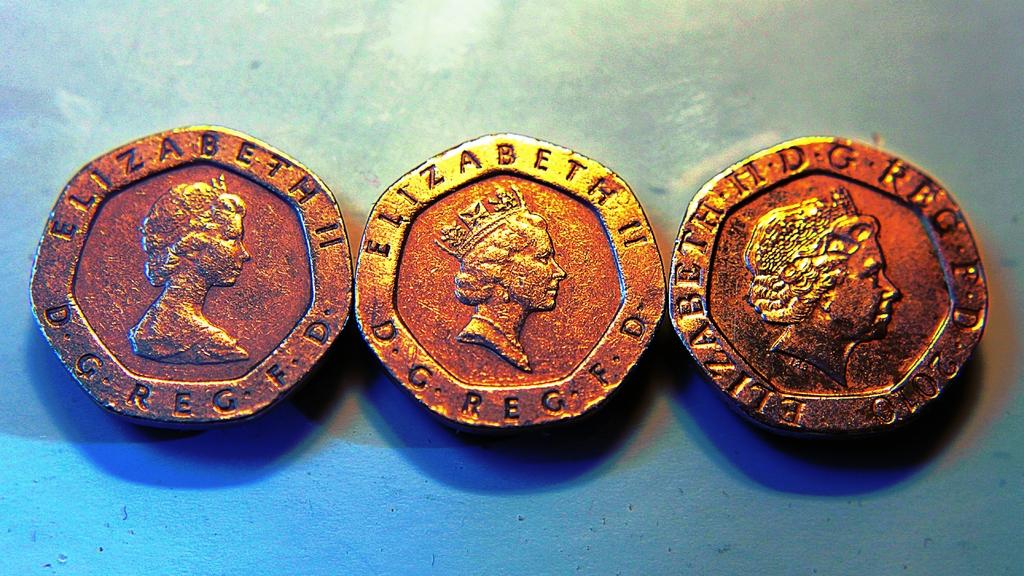What is the woman's name?
Offer a terse response. Elizabeth. What number is on the coin on the right?
Your answer should be compact. 2010. 